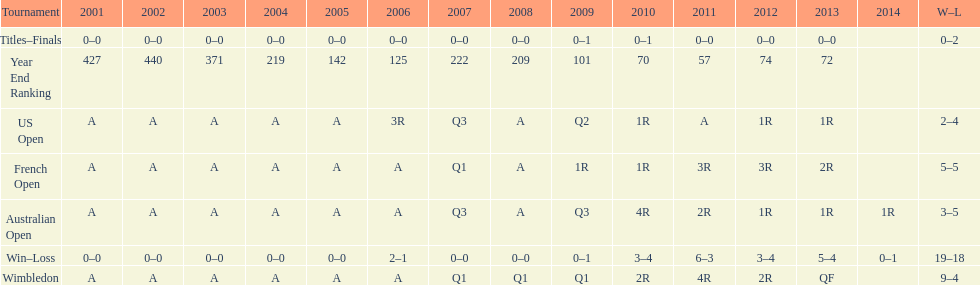What was this players ranking after 2005? 125. 